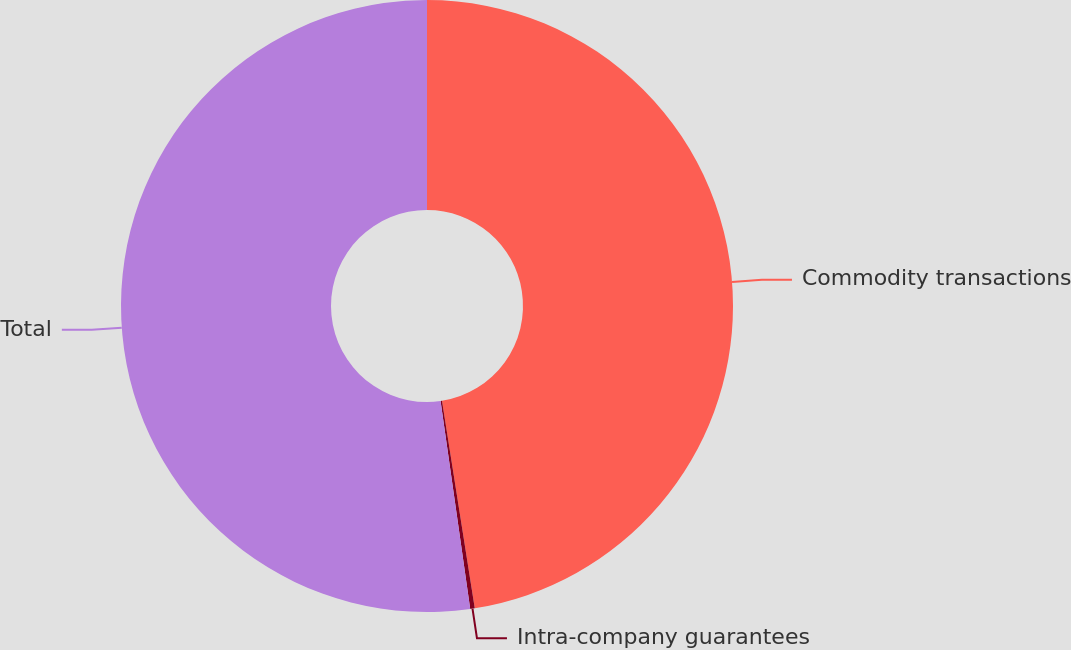<chart> <loc_0><loc_0><loc_500><loc_500><pie_chart><fcel>Commodity transactions<fcel>Intra-company guarantees<fcel>Total<nl><fcel>47.5%<fcel>0.24%<fcel>52.25%<nl></chart> 